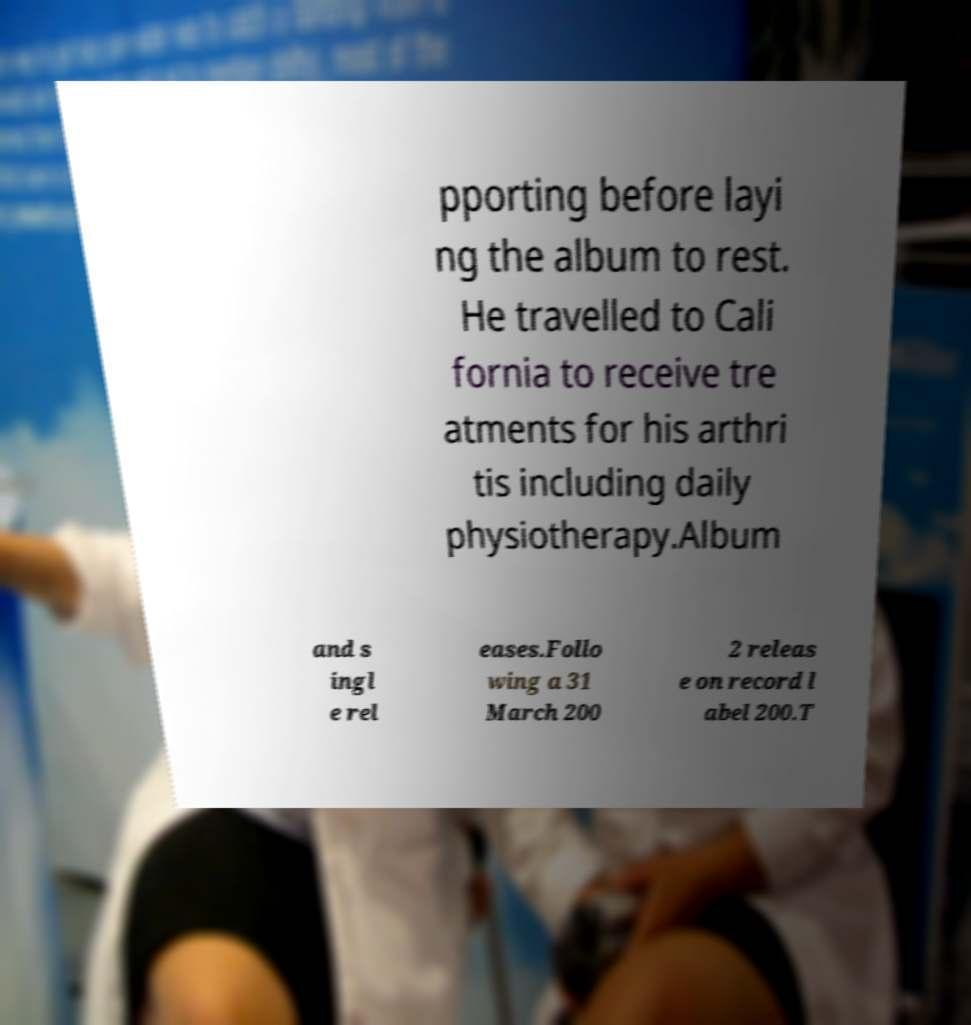What messages or text are displayed in this image? I need them in a readable, typed format. pporting before layi ng the album to rest. He travelled to Cali fornia to receive tre atments for his arthri tis including daily physiotherapy.Album and s ingl e rel eases.Follo wing a 31 March 200 2 releas e on record l abel 200.T 